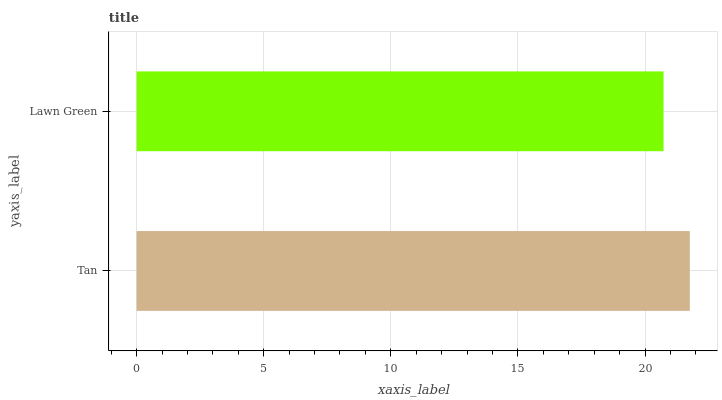Is Lawn Green the minimum?
Answer yes or no. Yes. Is Tan the maximum?
Answer yes or no. Yes. Is Lawn Green the maximum?
Answer yes or no. No. Is Tan greater than Lawn Green?
Answer yes or no. Yes. Is Lawn Green less than Tan?
Answer yes or no. Yes. Is Lawn Green greater than Tan?
Answer yes or no. No. Is Tan less than Lawn Green?
Answer yes or no. No. Is Tan the high median?
Answer yes or no. Yes. Is Lawn Green the low median?
Answer yes or no. Yes. Is Lawn Green the high median?
Answer yes or no. No. Is Tan the low median?
Answer yes or no. No. 